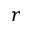Convert formula to latex. <formula><loc_0><loc_0><loc_500><loc_500>r</formula> 